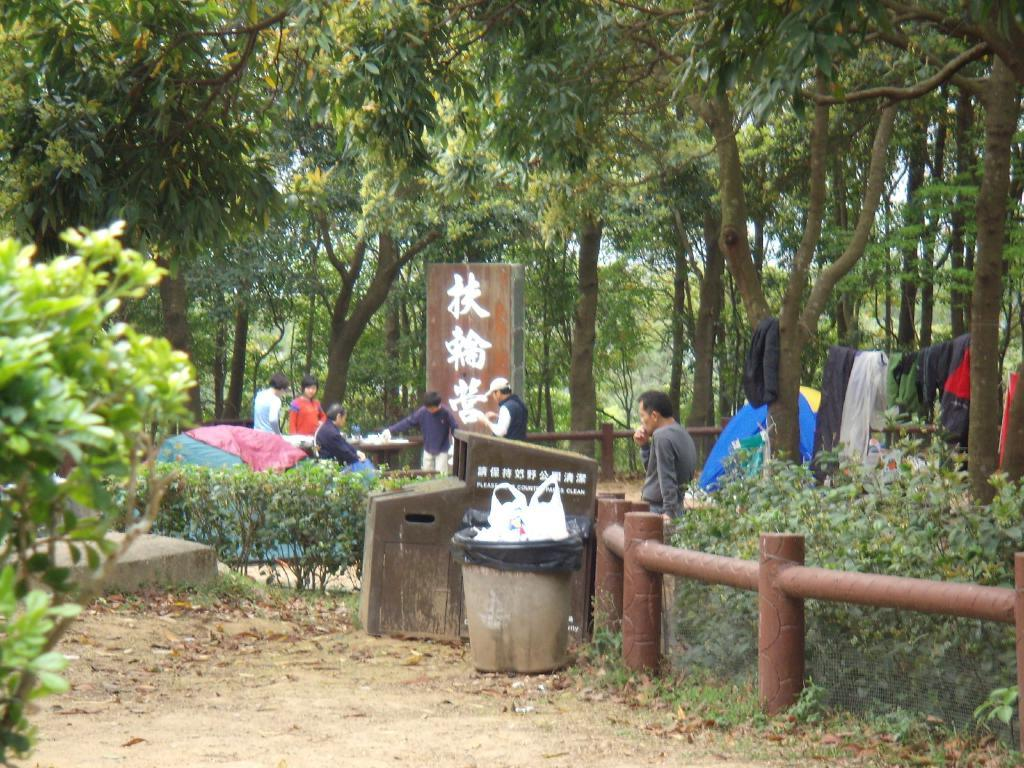What can be seen in the middle of the image? There are trees, plants, and persons standing in the middle of the image. What type of vegetation is present in the image? There are trees and plants in the middle of the image. What are the persons in the image doing? The persons are standing in the middle of the image. Where are the clothes located in the image? The clothes are on the right side of the image. How does the boot help the person stretch in the image? There is no boot present in the image, and therefore no stretching activity can be observed. 